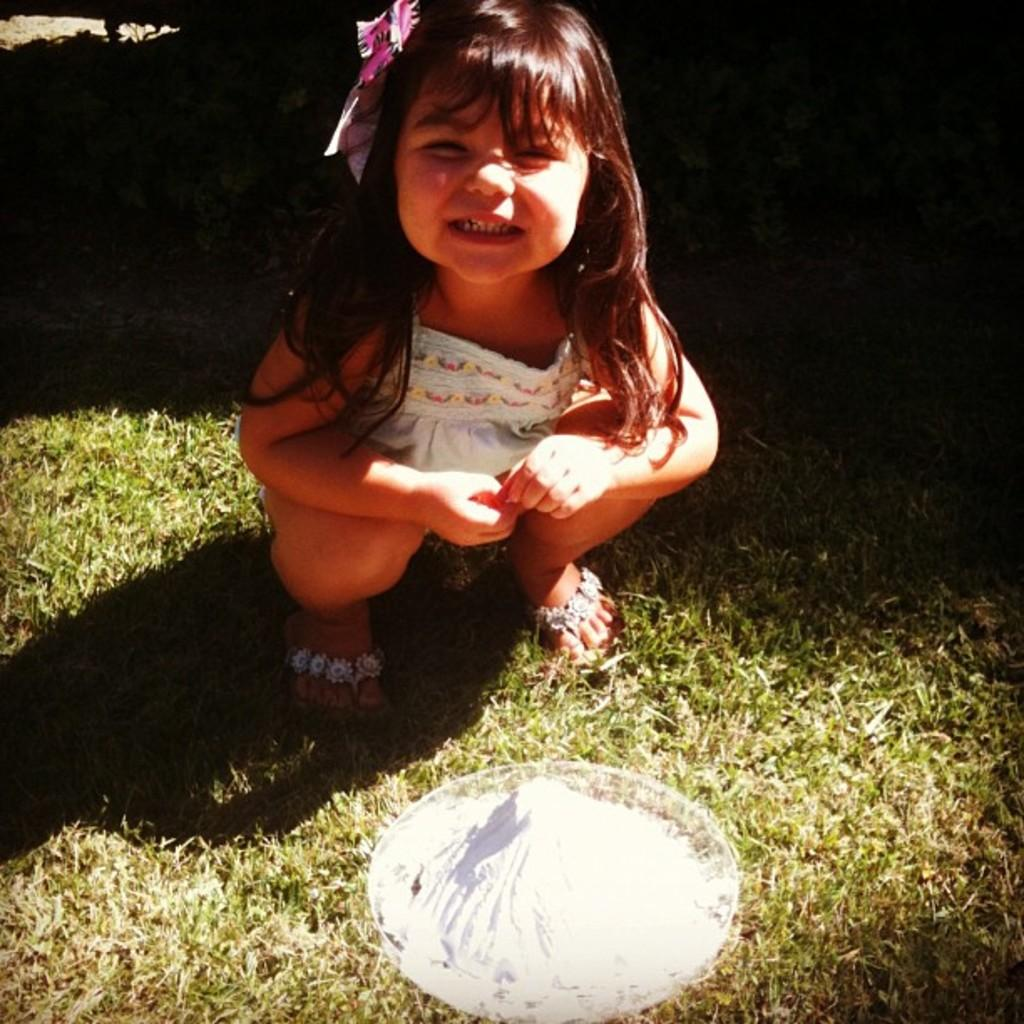What is the main subject of the image? The main subject of the image is a kid. What object is visible in the image besides the kid? There is a bowl in the image. Where is the bowl located? The bowl is on the grass. What is the price of the bells in the image? There are no bells present in the image, so it is not possible to determine their price. 